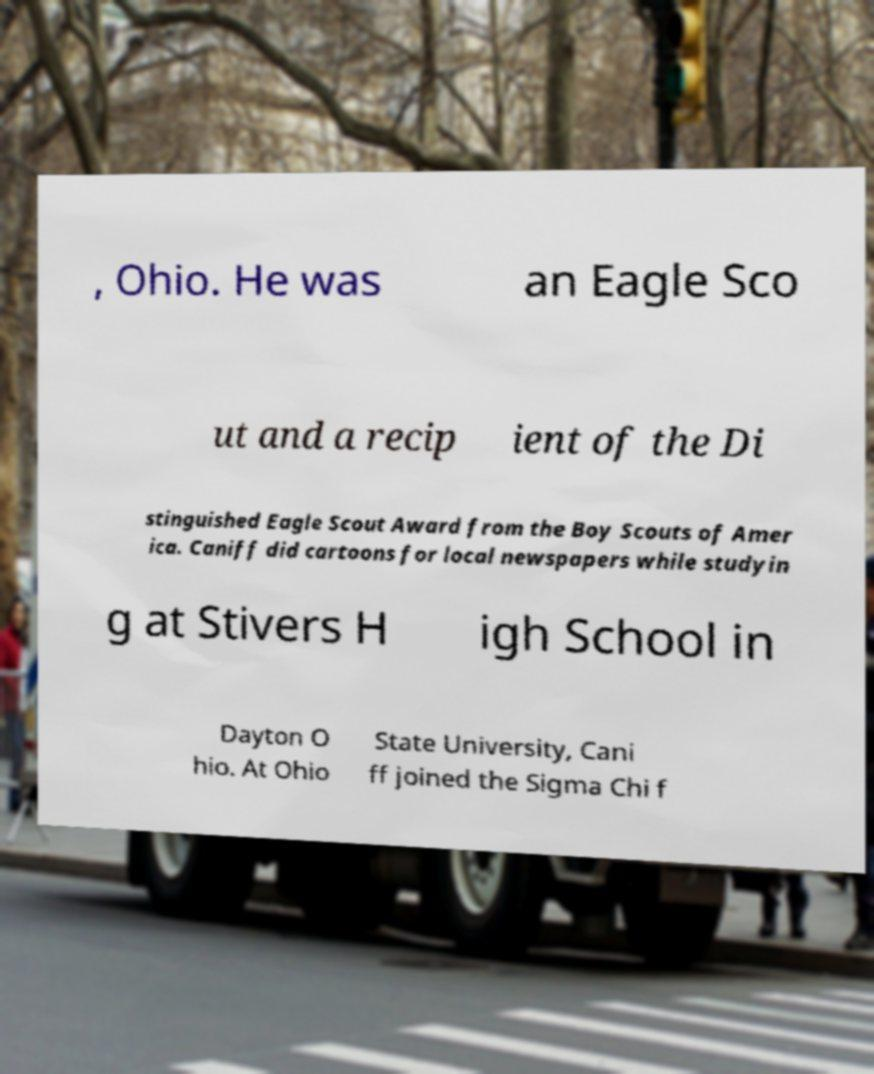Can you read and provide the text displayed in the image?This photo seems to have some interesting text. Can you extract and type it out for me? , Ohio. He was an Eagle Sco ut and a recip ient of the Di stinguished Eagle Scout Award from the Boy Scouts of Amer ica. Caniff did cartoons for local newspapers while studyin g at Stivers H igh School in Dayton O hio. At Ohio State University, Cani ff joined the Sigma Chi f 